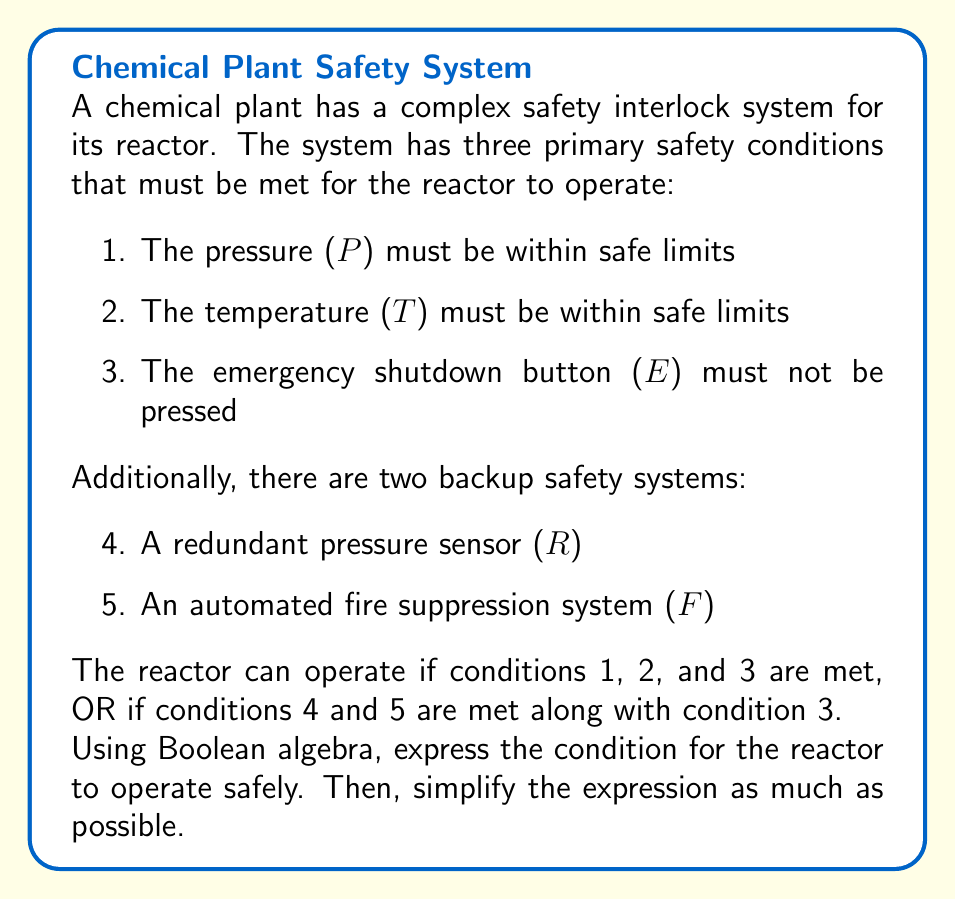Could you help me with this problem? Let's approach this step-by-step:

1) First, let's define our variables:
   P: Pressure within safe limits
   T: Temperature within safe limits
   E: Emergency shutdown button not pressed
   R: Redundant pressure sensor within safe limits
   F: Fire suppression system operational

2) The reactor can operate if:
   (P AND T AND E) OR (R AND F AND E)

3) We can express this in Boolean algebra as:
   $$(P \cdot T \cdot E) + (R \cdot F \cdot E)$$

4) Let's simplify this expression:
   $$(P \cdot T \cdot E) + (R \cdot F \cdot E)$$
   $$= E \cdot ((P \cdot T) + (R \cdot F))$$ (Factoring out E)

5) This is our simplified expression. It shows that:
   - The emergency shutdown button must not be pressed (E)
   - AND
   - Either the primary safety conditions (P and T) must be met
     OR
     the backup safety systems (R and F) must be operational

This Boolean expression accurately models the complex safety interlock system for the reactor.
Answer: $$E \cdot ((P \cdot T) + (R \cdot F))$$ 